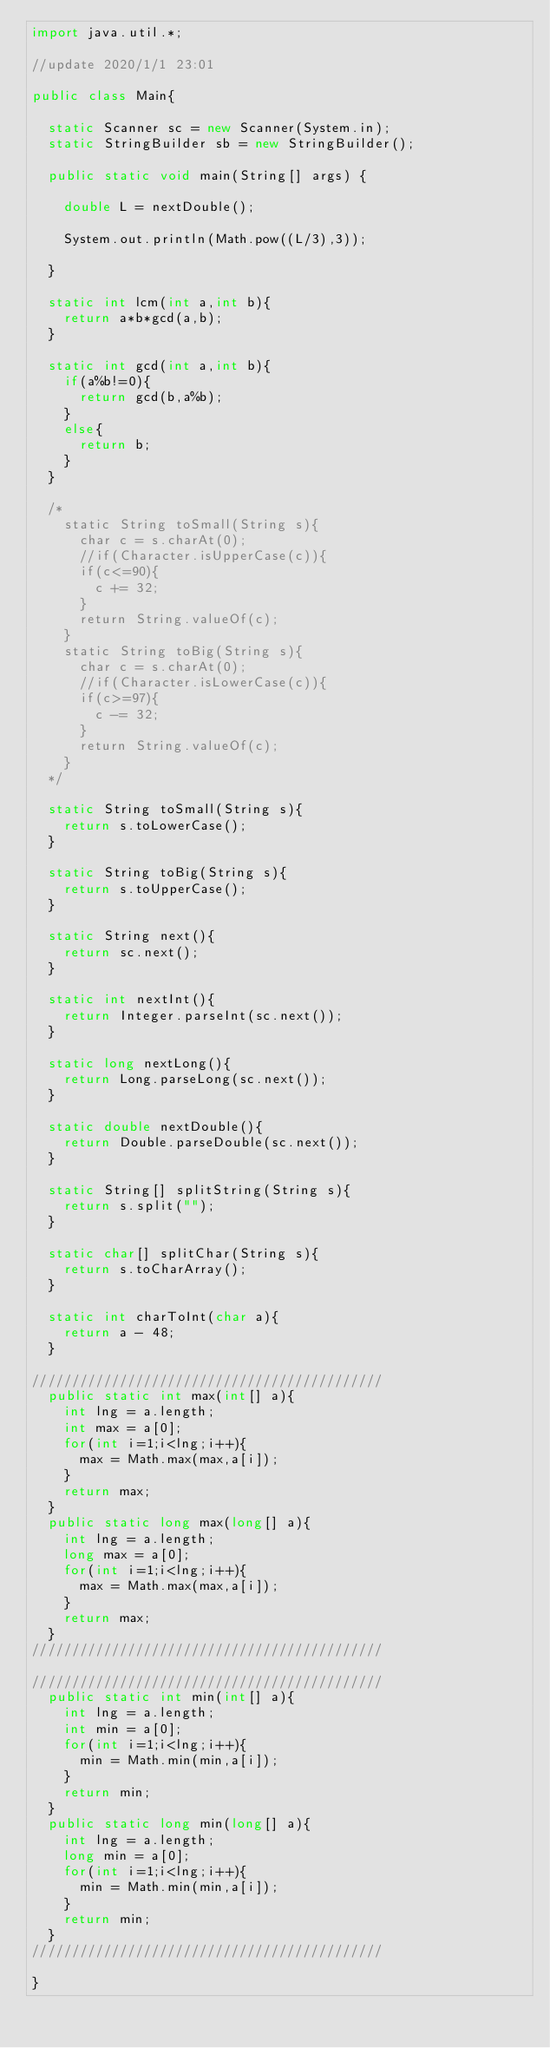Convert code to text. <code><loc_0><loc_0><loc_500><loc_500><_Java_>import java.util.*;

//update 2020/1/1 23:01

public class Main{

  static Scanner sc = new Scanner(System.in);
  static StringBuilder sb = new StringBuilder();

  public static void main(String[] args) {

    double L = nextDouble();

    System.out.println(Math.pow((L/3),3));

  }

  static int lcm(int a,int b){
    return a*b*gcd(a,b);
  }

  static int gcd(int a,int b){
    if(a%b!=0){
      return gcd(b,a%b);
    }
    else{
      return b;
    }
  }

  /*
    static String toSmall(String s){
      char c = s.charAt(0);
      //if(Character.isUpperCase(c)){
      if(c<=90){
        c += 32;
      }
      return String.valueOf(c);
    }
    static String toBig(String s){
      char c = s.charAt(0);
      //if(Character.isLowerCase(c)){
      if(c>=97){
        c -= 32;
      }
      return String.valueOf(c);
    }
  */

  static String toSmall(String s){
    return s.toLowerCase();
  }

  static String toBig(String s){
    return s.toUpperCase();
  }

  static String next(){
    return sc.next();
  }

  static int nextInt(){
    return Integer.parseInt(sc.next());
  }

  static long nextLong(){
    return Long.parseLong(sc.next());
  }

  static double nextDouble(){
    return Double.parseDouble(sc.next());
  }

  static String[] splitString(String s){
    return s.split("");
  }

  static char[] splitChar(String s){
    return s.toCharArray();
  }

  static int charToInt(char a){
    return a - 48;
  }

////////////////////////////////////////////
  public static int max(int[] a){
    int lng = a.length;
    int max = a[0];
    for(int i=1;i<lng;i++){
      max = Math.max(max,a[i]);
    }
    return max;
  }
  public static long max(long[] a){
    int lng = a.length;
    long max = a[0];
    for(int i=1;i<lng;i++){
      max = Math.max(max,a[i]);
    }
    return max;
  }
////////////////////////////////////////////

////////////////////////////////////////////
  public static int min(int[] a){
    int lng = a.length;
    int min = a[0];
    for(int i=1;i<lng;i++){
      min = Math.min(min,a[i]);
    }
    return min;
  }
  public static long min(long[] a){
    int lng = a.length;
    long min = a[0];
    for(int i=1;i<lng;i++){
      min = Math.min(min,a[i]);
    }
    return min;
  }
////////////////////////////////////////////

}
</code> 